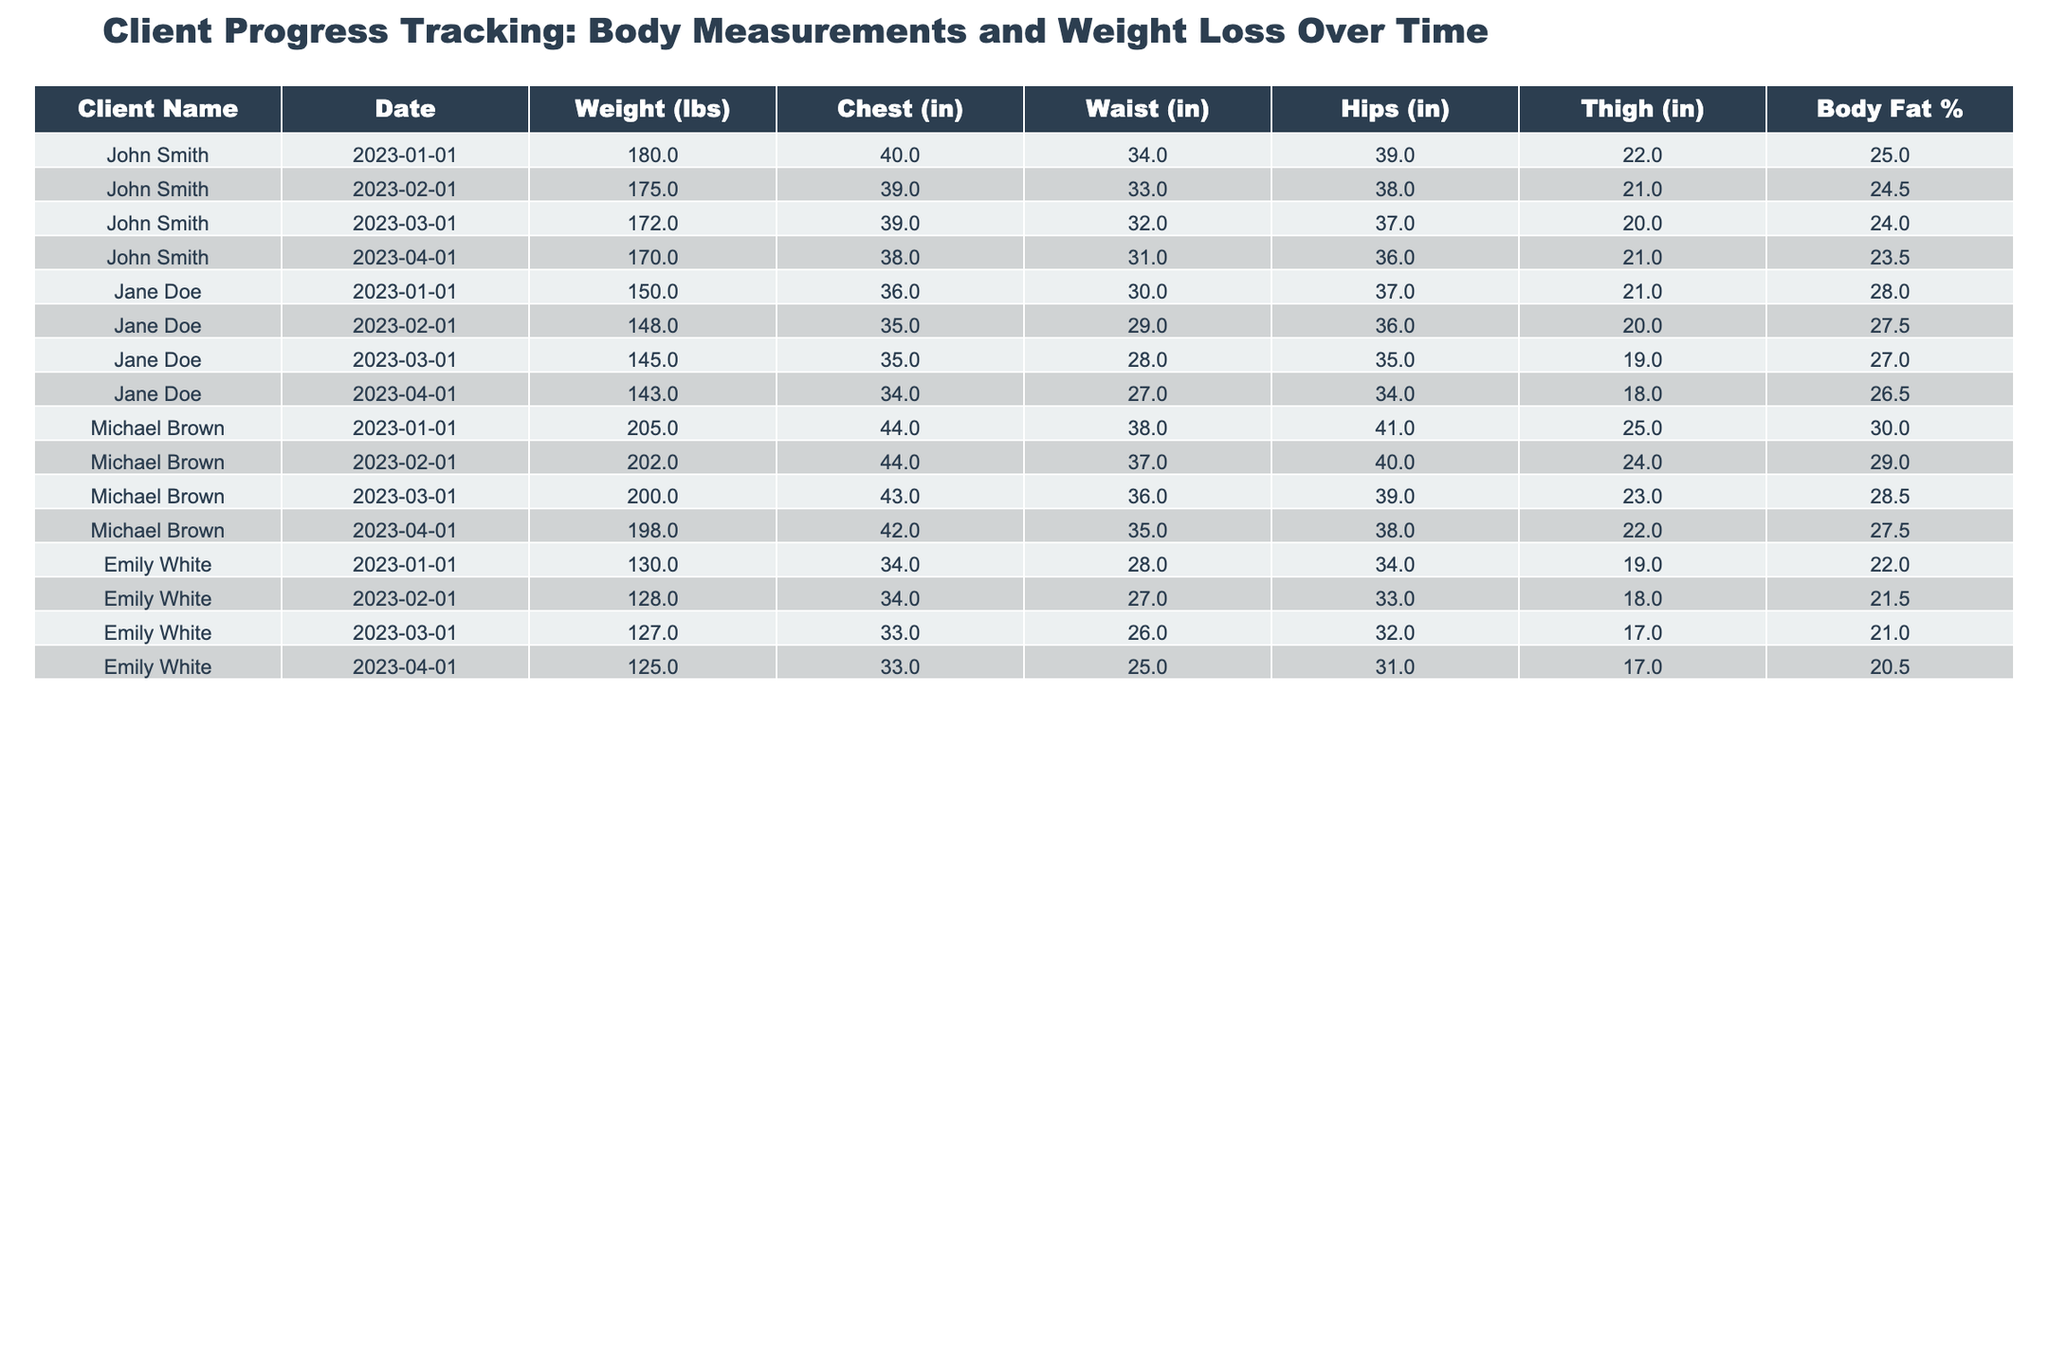What was Jane Doe's weight on 2023-03-01? Referring to the table, the weight of Jane Doe listed for the date 2023-03-01 is 145 lbs.
Answer: 145 lbs What is the average body fat percentage for Michael Brown over the recorded months? To find the average body fat percentage for Michael Brown, sum the values from each month: (30.0 + 29.0 + 28.5 + 27.5) = 115.0. Then, divide by the number of months (4): 115.0 / 4 = 28.75.
Answer: 28.75 Did John Smith reduce his waist measurement from January to April? By examining the waist measurements for John Smith from the table, in January it was 34 inches and in April it was 31 inches. Since 34 inches is greater than 31 inches, he did reduce his waist measurement.
Answer: Yes What was the total weight loss for Emily White from January to April? Emily White's weight on January 1 was 130 lbs and on April 1 it was 125 lbs. To find the weight loss, subtract the final weight from the initial weight: 130 - 125 = 5 lbs of weight loss.
Answer: 5 lbs Which client had the highest chest measurement on 2023-01-01, and what was it? The table shows the chest measurements for all clients on January 1, 2023. John Smith had a chest measurement of 40 inches, Jane Doe had 36 inches, Michael Brown had 44 inches, and Emily White had 34 inches. The highest chest measurement is therefore Michael Brown's at 44 inches.
Answer: 44 inches What is the percentage change in weight for John Smith from February to April? John Smith's weight on February 1 was 175 lbs and on April 1 it was 170 lbs. To calculate percentage change, use the formula: [(New weight - Old weight) / Old weight] * 100. This gives us: [(170 - 175) / 175] * 100 = (-5 / 175) * 100 ≈ -2.86%.
Answer: -2.86% Did Emily White's body fat percentage decrease over the recorded months? Looking at the body fat percentage for Emily White, it decreased from 22.0% in January to 20.5% in April. By checking the value for each month, we observe that it consistently declined each month from January to April.
Answer: Yes How many inches did Michael Brown's waist measurement decrease from January to April? Michael Brown's waist measurement on January 1 was 38 inches, and on April 1 it was 35 inches. Subtracting gives us: 38 - 35 = 3 inches of decrease in waist measurement.
Answer: 3 inches 